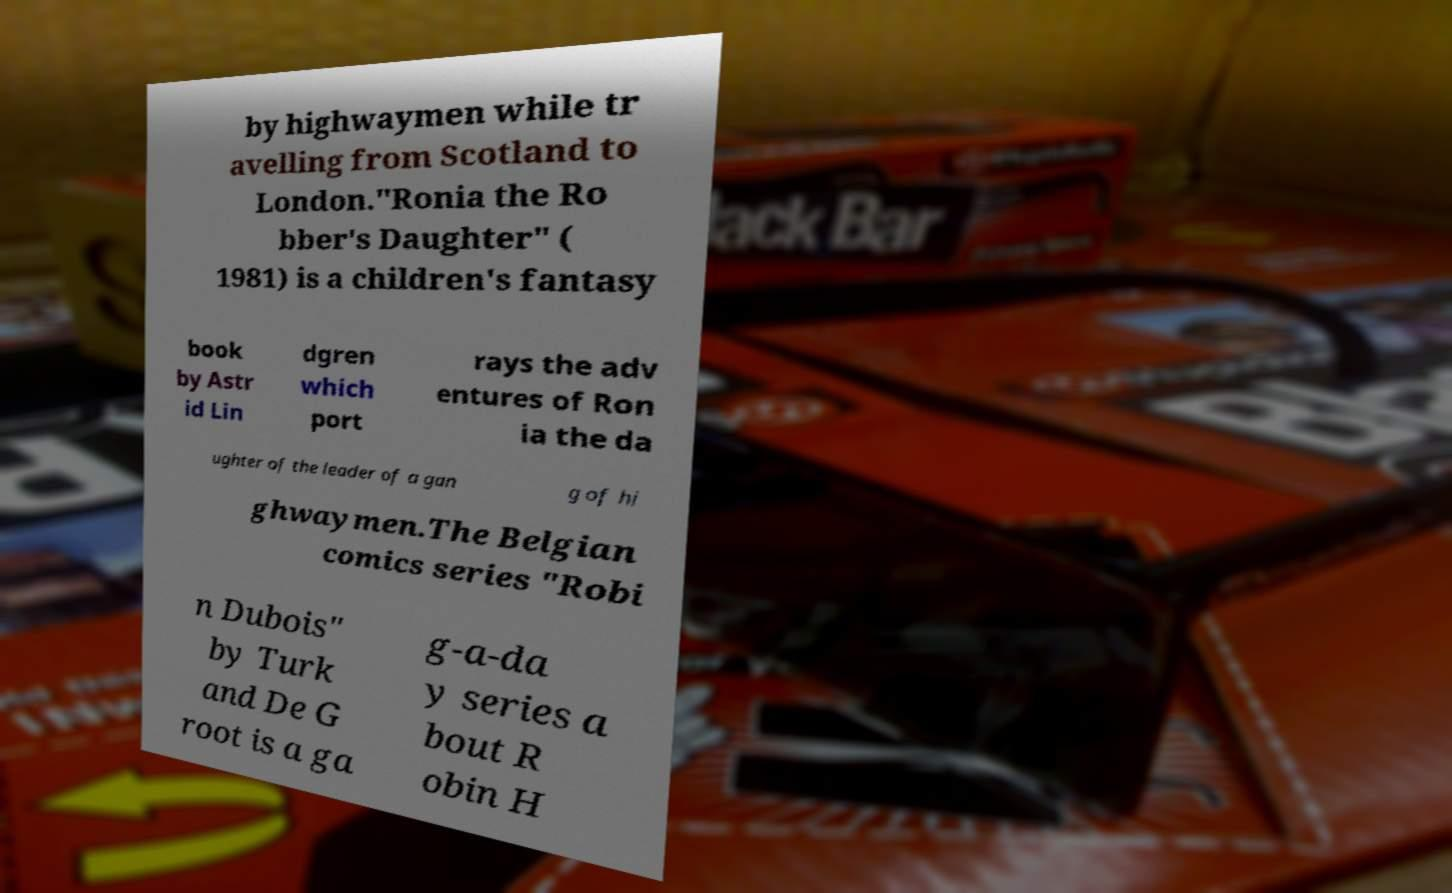Could you assist in decoding the text presented in this image and type it out clearly? by highwaymen while tr avelling from Scotland to London."Ronia the Ro bber's Daughter" ( 1981) is a children's fantasy book by Astr id Lin dgren which port rays the adv entures of Ron ia the da ughter of the leader of a gan g of hi ghwaymen.The Belgian comics series "Robi n Dubois" by Turk and De G root is a ga g-a-da y series a bout R obin H 